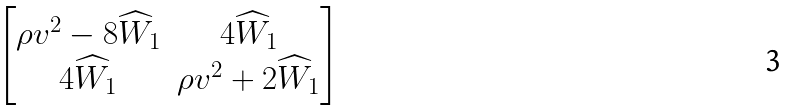Convert formula to latex. <formula><loc_0><loc_0><loc_500><loc_500>\begin{bmatrix} \rho v ^ { 2 } - 8 \widehat { W } _ { 1 } & 4 \widehat { W } _ { 1 } \\ 4 \widehat { W } _ { 1 } & \rho v ^ { 2 } + 2 \widehat { W } _ { 1 } \end{bmatrix}</formula> 